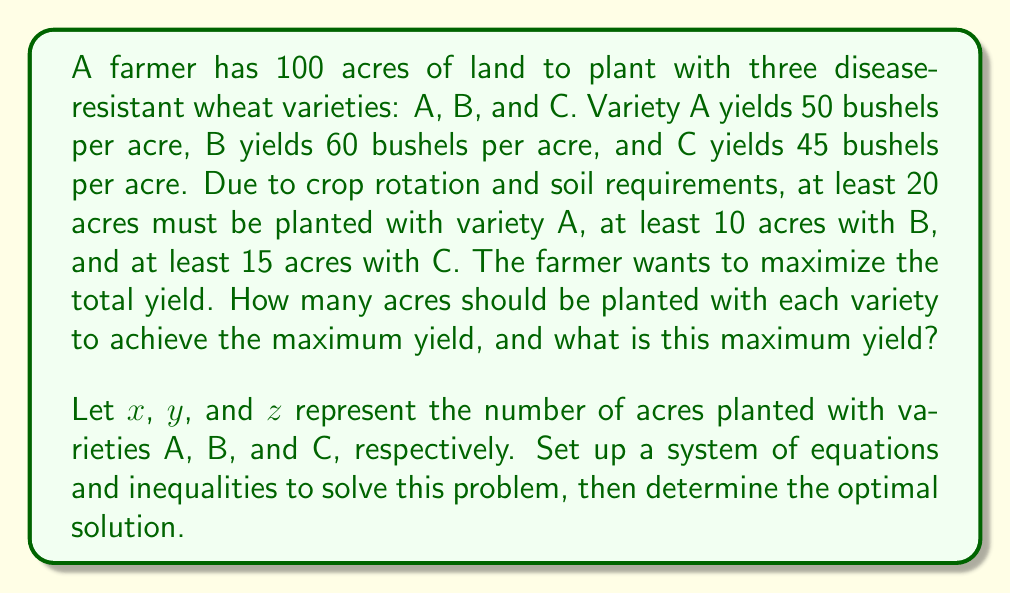What is the answer to this math problem? To solve this problem, we need to set up a linear programming model and use the simplex method or graphical method. Let's break it down step by step:

1. Define variables:
   $x$ = acres of variety A
   $y$ = acres of variety B
   $z$ = acres of variety C

2. Objective function (total yield to maximize):
   $$f(x,y,z) = 50x + 60y + 45z$$

3. Constraints:
   Total land: $x + y + z = 100$
   Minimum for A: $x \geq 20$
   Minimum for B: $y \geq 10$
   Minimum for C: $z \geq 15$
   Non-negativity: $x, y, z \geq 0$

4. To solve this, we can use the simplex method or a graphical approach. Given the constraints, we can simplify the problem by substituting $z = 100 - x - y$ into the objective function:

   $$f(x,y) = 50x + 60y + 45(100 - x - y) = 5x + 15y + 4500$$

5. The feasible region is bounded by:
   $x \geq 20$
   $y \geq 10$
   $z \geq 15$, which is equivalent to $x + y \leq 85$

6. The optimal solution will be at one of the corner points of this feasible region. The corner points are:
   (20, 10), (20, 65), (70, 10)

7. Evaluating the objective function at these points:
   f(20, 10) = 5(20) + 15(10) + 4500 = 4750
   f(20, 65) = 5(20) + 15(65) + 4500 = 5575
   f(70, 10) = 5(70) + 15(10) + 4500 = 5000

8. The maximum yield is achieved at the point (20, 65), which corresponds to:
   x = 20 acres of variety A
   y = 65 acres of variety B
   z = 15 acres of variety C

9. The maximum yield is 5575 bushels.
Answer: The optimal mix is 20 acres of variety A, 65 acres of variety B, and 15 acres of variety C. The maximum yield is 5575 bushels. 